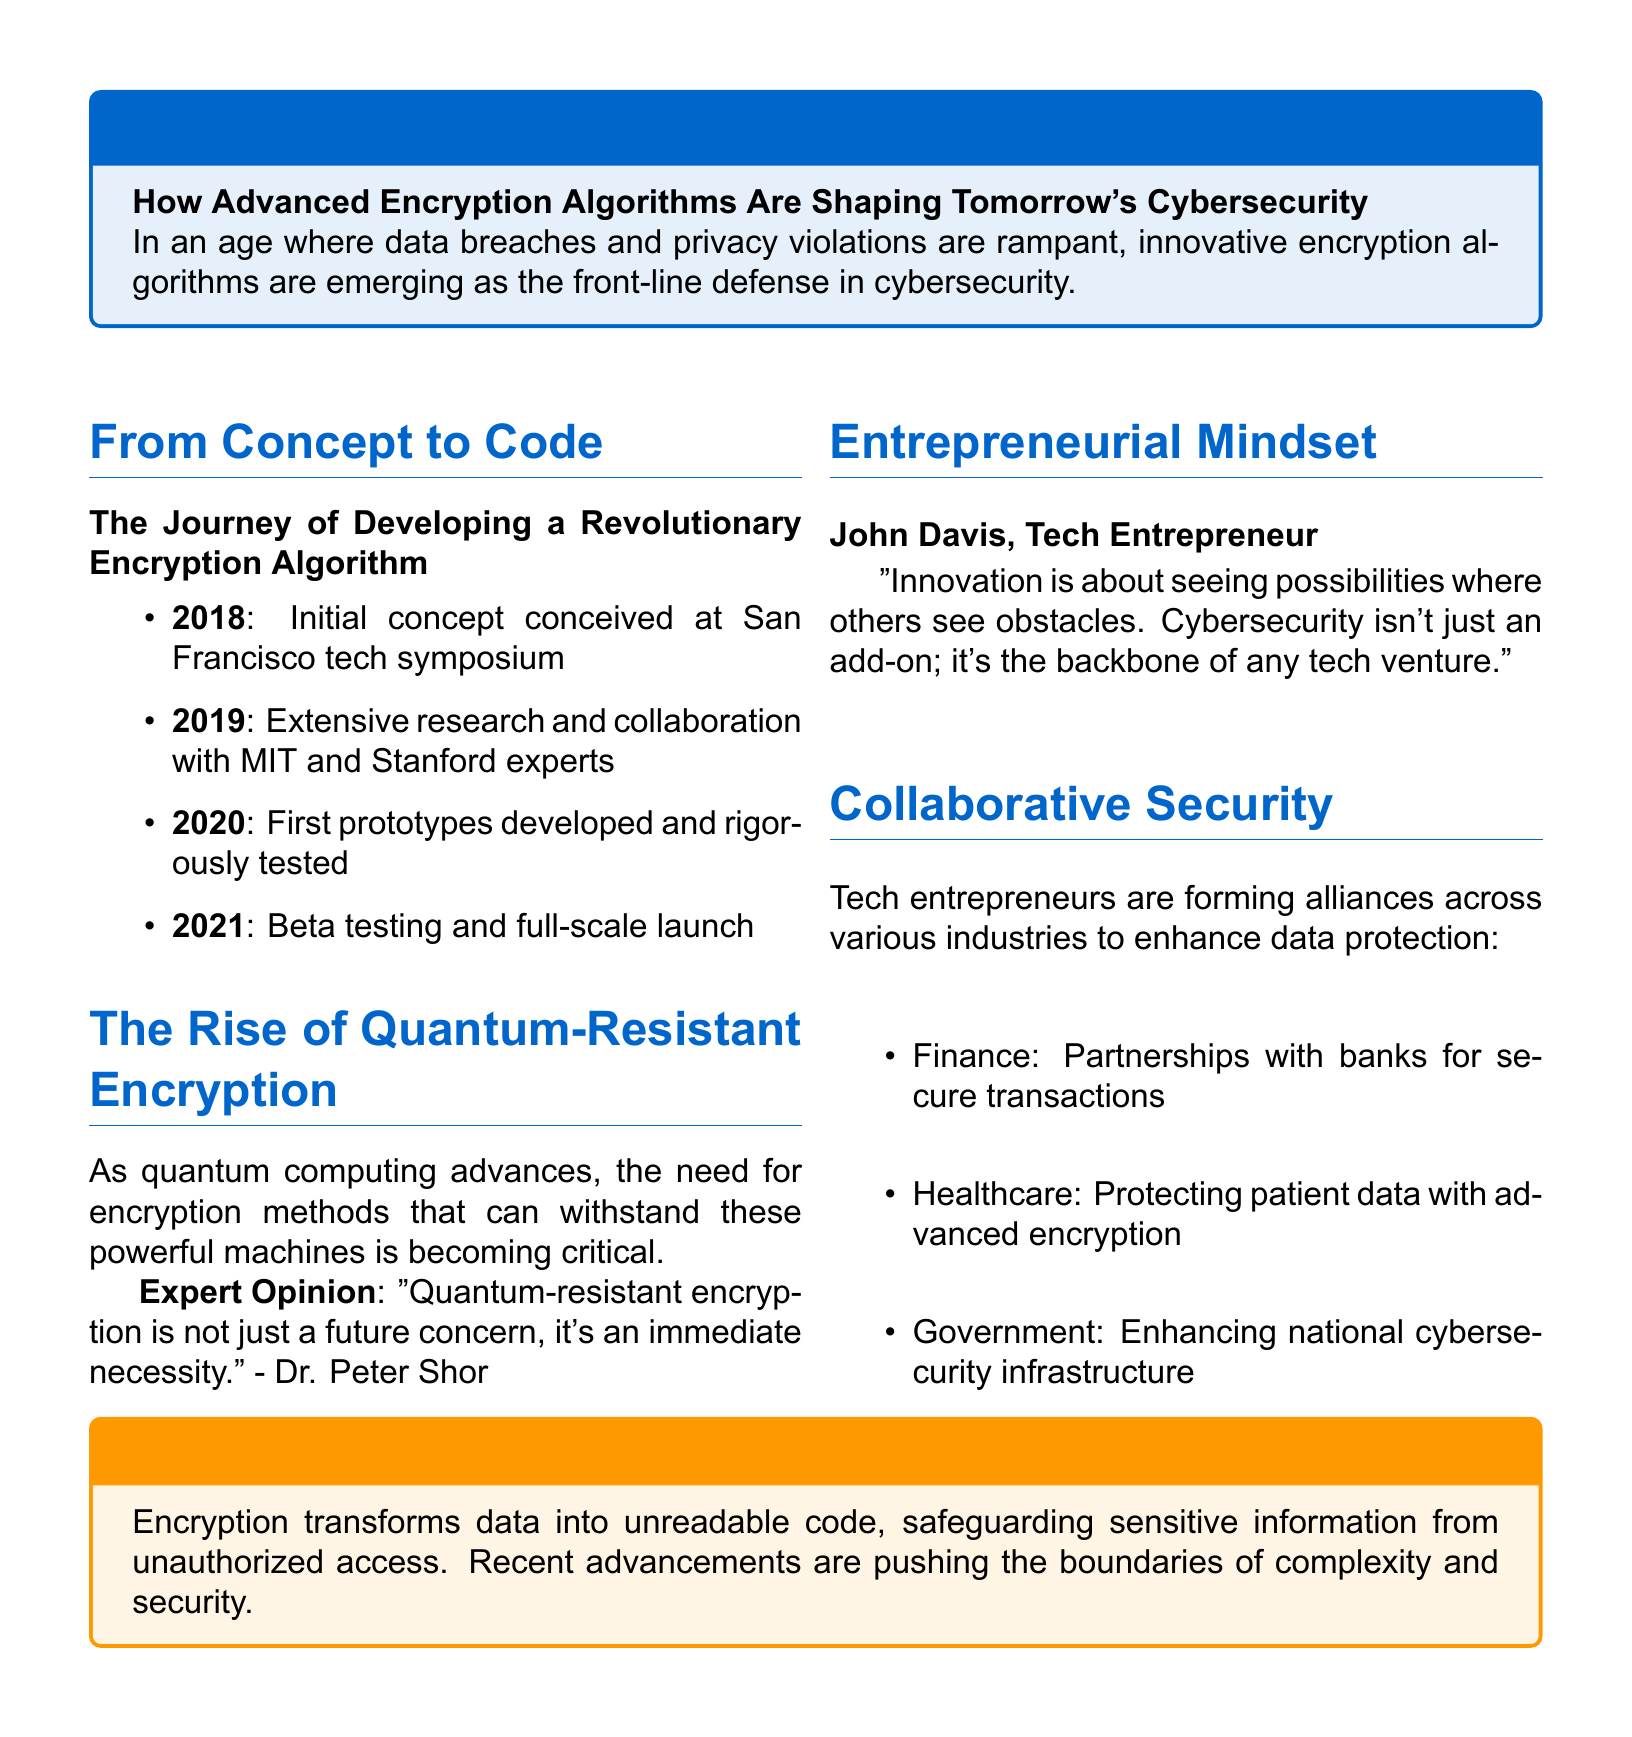What is the title of the feature article? The title is explicitly mentioned in the document's tcolorbox section as "Securing the Future".
Answer: Securing the Future In what year was the initial concept of the encryption algorithm conceived? The document lists the year it was conceived as 2018 in the timeline.
Answer: 2018 Who is quoted regarding the importance of quantum-resistant encryption? The document attributes the quote to Dr. Peter Shor.
Answer: Dr. Peter Shor What industry is mentioned alongside partnerships in finance and healthcare? The document lists government as an industry involved in partnerships for enhancing data protection.
Answer: Government What is the role of encryption according to the document? The document states that encryption transforms data into unreadable code to safeguard sensitive information.
Answer: Safeguarding sensitive information What does the entrepreneurial mindset emphasize according to John Davis? The quote highlights that cybersecurity is the backbone of any tech venture.
Answer: The backbone of any tech venture How many years does the timeline cover for the development process? The timeline spans from 2018 to 2021, covering four years.
Answer: Four years What color is used for the primary title formatting? The primary title color is specified in the document as RGB(0,102,204).
Answer: RGB(0,102,204) What is the subtitle of the section on collaborative security? The subtitle is "Enhancing Data Protection Through Cross-Industry Partnerships".
Answer: Enhancing Data Protection Through Cross-Industry Partnerships 